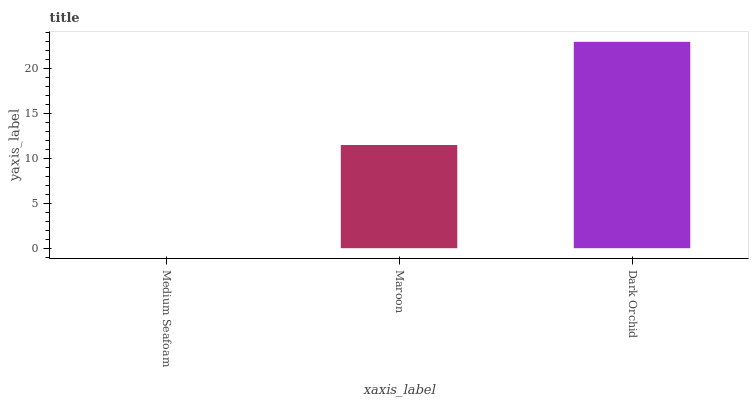Is Medium Seafoam the minimum?
Answer yes or no. Yes. Is Dark Orchid the maximum?
Answer yes or no. Yes. Is Maroon the minimum?
Answer yes or no. No. Is Maroon the maximum?
Answer yes or no. No. Is Maroon greater than Medium Seafoam?
Answer yes or no. Yes. Is Medium Seafoam less than Maroon?
Answer yes or no. Yes. Is Medium Seafoam greater than Maroon?
Answer yes or no. No. Is Maroon less than Medium Seafoam?
Answer yes or no. No. Is Maroon the high median?
Answer yes or no. Yes. Is Maroon the low median?
Answer yes or no. Yes. Is Medium Seafoam the high median?
Answer yes or no. No. Is Medium Seafoam the low median?
Answer yes or no. No. 